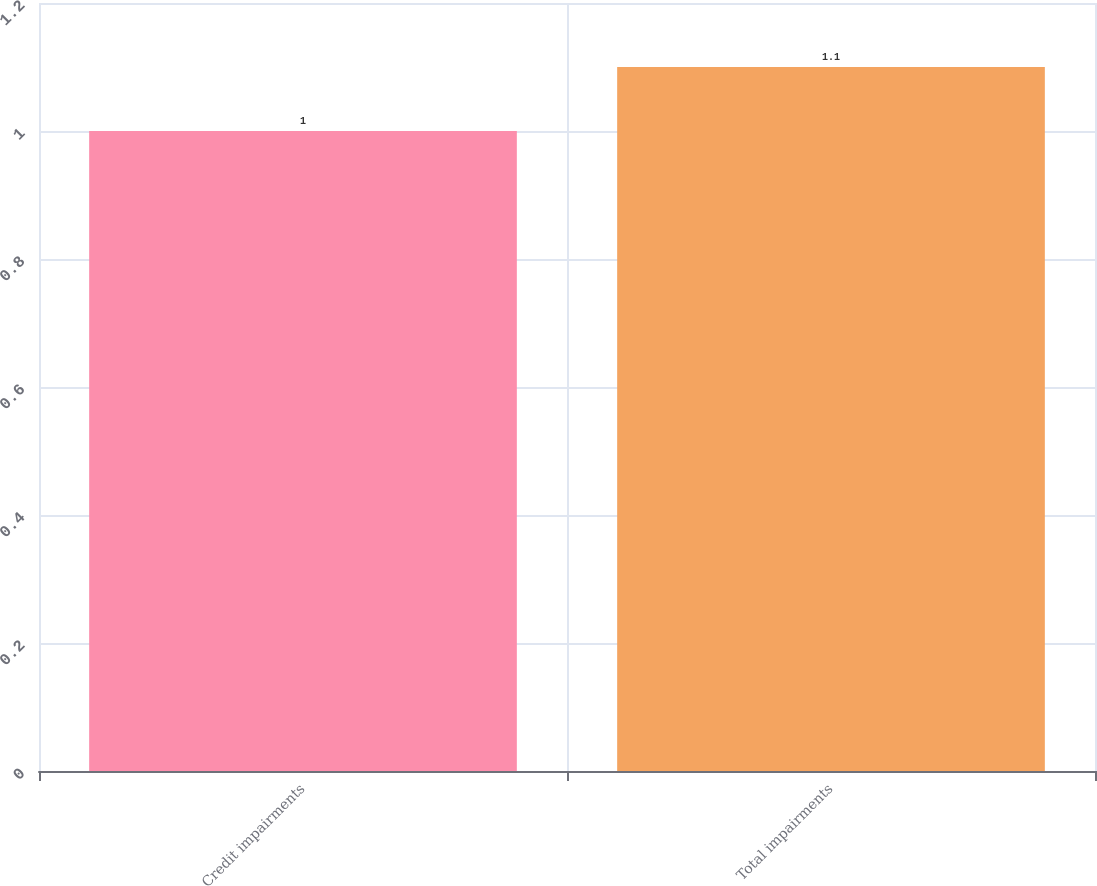Convert chart to OTSL. <chart><loc_0><loc_0><loc_500><loc_500><bar_chart><fcel>Credit impairments<fcel>Total impairments<nl><fcel>1<fcel>1.1<nl></chart> 